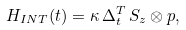Convert formula to latex. <formula><loc_0><loc_0><loc_500><loc_500>H _ { I N T } ( t ) = \kappa \, \Delta ^ { T } _ { t } \, S _ { z } \otimes p ,</formula> 